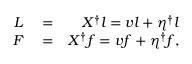Convert formula to latex. <formula><loc_0><loc_0><loc_500><loc_500>\begin{array} { r l r } { L } & = } & { X ^ { \dagger } l = v l + \eta ^ { \dagger } l } \\ { F } & = } & { X ^ { \dagger } f = v f + \eta ^ { \dagger } f , } \end{array}</formula> 